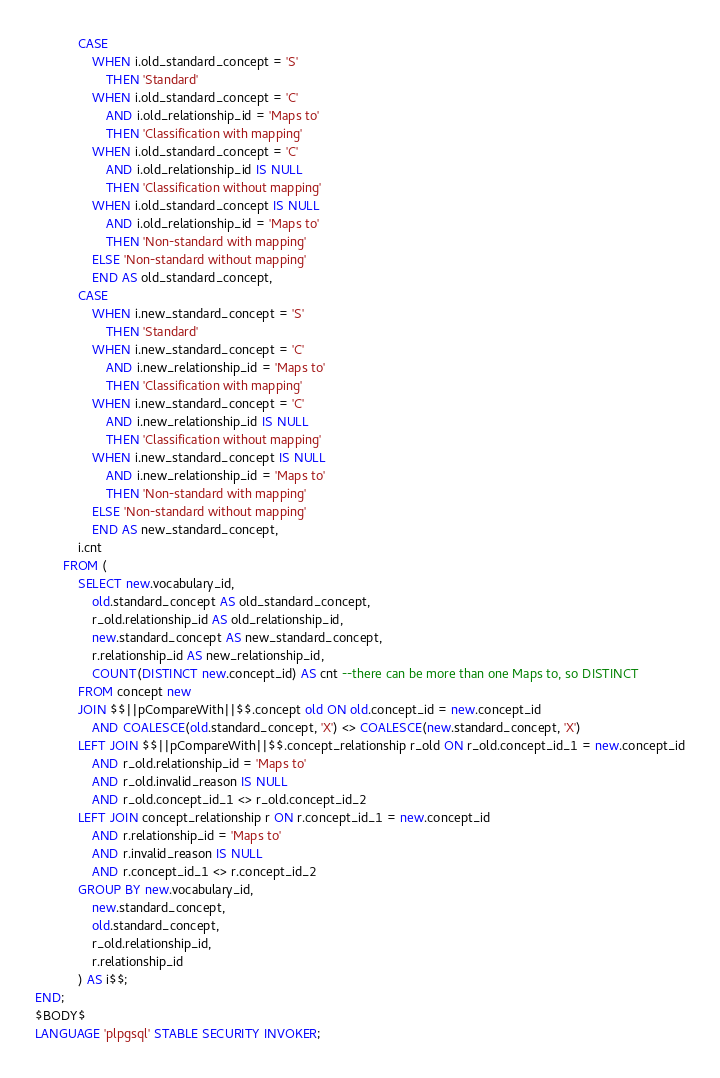<code> <loc_0><loc_0><loc_500><loc_500><_SQL_>			CASE 
				WHEN i.old_standard_concept = 'S'
					THEN 'Standard'
				WHEN i.old_standard_concept = 'C'
					AND i.old_relationship_id = 'Maps to'
					THEN 'Classification with mapping'
				WHEN i.old_standard_concept = 'C'
					AND i.old_relationship_id IS NULL
					THEN 'Classification without mapping'
				WHEN i.old_standard_concept IS NULL
					AND i.old_relationship_id = 'Maps to'
					THEN 'Non-standard with mapping'
				ELSE 'Non-standard without mapping'
				END AS old_standard_concept,
			CASE 
				WHEN i.new_standard_concept = 'S'
					THEN 'Standard'
				WHEN i.new_standard_concept = 'C'
					AND i.new_relationship_id = 'Maps to'
					THEN 'Classification with mapping'
				WHEN i.new_standard_concept = 'C'
					AND i.new_relationship_id IS NULL
					THEN 'Classification without mapping'
				WHEN i.new_standard_concept IS NULL
					AND i.new_relationship_id = 'Maps to'
					THEN 'Non-standard with mapping'
				ELSE 'Non-standard without mapping'
				END AS new_standard_concept,
			i.cnt
		FROM (
			SELECT new.vocabulary_id,
				old.standard_concept AS old_standard_concept,
				r_old.relationship_id AS old_relationship_id,
				new.standard_concept AS new_standard_concept,
				r.relationship_id AS new_relationship_id,
				COUNT(DISTINCT new.concept_id) AS cnt --there can be more than one Maps to, so DISTINCT
			FROM concept new
			JOIN $$||pCompareWith||$$.concept old ON old.concept_id = new.concept_id
				AND COALESCE(old.standard_concept, 'X') <> COALESCE(new.standard_concept, 'X')
			LEFT JOIN $$||pCompareWith||$$.concept_relationship r_old ON r_old.concept_id_1 = new.concept_id
				AND r_old.relationship_id = 'Maps to'
				AND r_old.invalid_reason IS NULL
				AND r_old.concept_id_1 <> r_old.concept_id_2
			LEFT JOIN concept_relationship r ON r.concept_id_1 = new.concept_id
				AND r.relationship_id = 'Maps to'
				AND r.invalid_reason IS NULL
				AND r.concept_id_1 <> r.concept_id_2
			GROUP BY new.vocabulary_id,
				new.standard_concept,
				old.standard_concept,
				r_old.relationship_id,
				r.relationship_id
			) AS i$$;
END;
$BODY$
LANGUAGE 'plpgsql' STABLE SECURITY INVOKER;</code> 